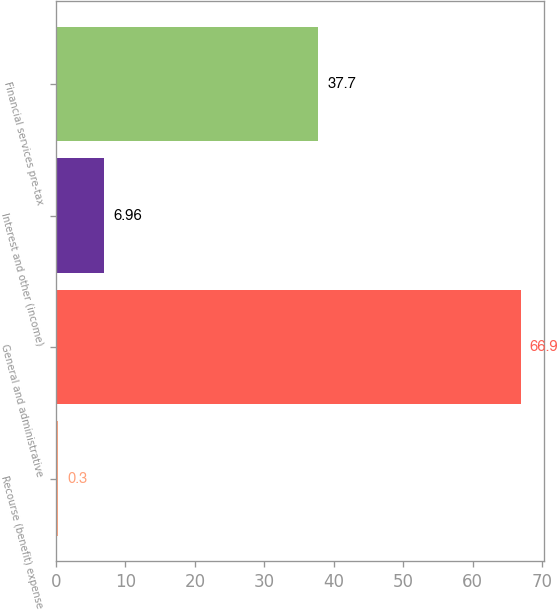Convert chart to OTSL. <chart><loc_0><loc_0><loc_500><loc_500><bar_chart><fcel>Recourse (benefit) expense<fcel>General and administrative<fcel>Interest and other (income)<fcel>Financial services pre-tax<nl><fcel>0.3<fcel>66.9<fcel>6.96<fcel>37.7<nl></chart> 